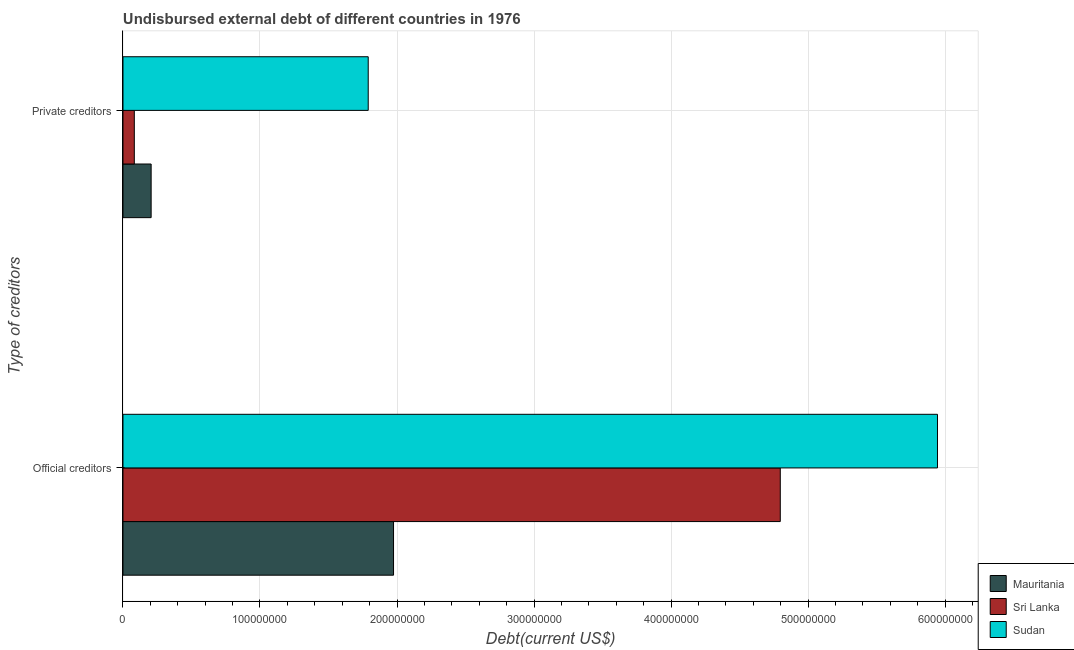Are the number of bars per tick equal to the number of legend labels?
Your response must be concise. Yes. How many bars are there on the 1st tick from the bottom?
Provide a succinct answer. 3. What is the label of the 2nd group of bars from the top?
Provide a short and direct response. Official creditors. What is the undisbursed external debt of private creditors in Sudan?
Provide a short and direct response. 1.79e+08. Across all countries, what is the maximum undisbursed external debt of official creditors?
Offer a very short reply. 5.94e+08. Across all countries, what is the minimum undisbursed external debt of official creditors?
Your answer should be very brief. 1.97e+08. In which country was the undisbursed external debt of private creditors maximum?
Offer a very short reply. Sudan. In which country was the undisbursed external debt of official creditors minimum?
Your response must be concise. Mauritania. What is the total undisbursed external debt of official creditors in the graph?
Provide a succinct answer. 1.27e+09. What is the difference between the undisbursed external debt of official creditors in Sudan and that in Mauritania?
Provide a succinct answer. 3.97e+08. What is the difference between the undisbursed external debt of private creditors in Mauritania and the undisbursed external debt of official creditors in Sri Lanka?
Provide a short and direct response. -4.59e+08. What is the average undisbursed external debt of private creditors per country?
Offer a very short reply. 6.93e+07. What is the difference between the undisbursed external debt of official creditors and undisbursed external debt of private creditors in Sri Lanka?
Your answer should be very brief. 4.71e+08. In how many countries, is the undisbursed external debt of official creditors greater than 340000000 US$?
Your answer should be very brief. 2. What is the ratio of the undisbursed external debt of official creditors in Sri Lanka to that in Sudan?
Your answer should be compact. 0.81. In how many countries, is the undisbursed external debt of private creditors greater than the average undisbursed external debt of private creditors taken over all countries?
Your response must be concise. 1. What does the 1st bar from the top in Private creditors represents?
Provide a short and direct response. Sudan. What does the 3rd bar from the bottom in Official creditors represents?
Offer a very short reply. Sudan. How many countries are there in the graph?
Give a very brief answer. 3. What is the difference between two consecutive major ticks on the X-axis?
Keep it short and to the point. 1.00e+08. Are the values on the major ticks of X-axis written in scientific E-notation?
Provide a short and direct response. No. Does the graph contain grids?
Give a very brief answer. Yes. How many legend labels are there?
Provide a short and direct response. 3. What is the title of the graph?
Make the answer very short. Undisbursed external debt of different countries in 1976. What is the label or title of the X-axis?
Provide a succinct answer. Debt(current US$). What is the label or title of the Y-axis?
Offer a terse response. Type of creditors. What is the Debt(current US$) in Mauritania in Official creditors?
Your response must be concise. 1.97e+08. What is the Debt(current US$) of Sri Lanka in Official creditors?
Provide a short and direct response. 4.80e+08. What is the Debt(current US$) of Sudan in Official creditors?
Your response must be concise. 5.94e+08. What is the Debt(current US$) in Mauritania in Private creditors?
Keep it short and to the point. 2.05e+07. What is the Debt(current US$) in Sri Lanka in Private creditors?
Keep it short and to the point. 8.28e+06. What is the Debt(current US$) in Sudan in Private creditors?
Give a very brief answer. 1.79e+08. Across all Type of creditors, what is the maximum Debt(current US$) of Mauritania?
Your answer should be compact. 1.97e+08. Across all Type of creditors, what is the maximum Debt(current US$) in Sri Lanka?
Keep it short and to the point. 4.80e+08. Across all Type of creditors, what is the maximum Debt(current US$) of Sudan?
Offer a very short reply. 5.94e+08. Across all Type of creditors, what is the minimum Debt(current US$) of Mauritania?
Your response must be concise. 2.05e+07. Across all Type of creditors, what is the minimum Debt(current US$) in Sri Lanka?
Offer a very short reply. 8.28e+06. Across all Type of creditors, what is the minimum Debt(current US$) of Sudan?
Provide a short and direct response. 1.79e+08. What is the total Debt(current US$) in Mauritania in the graph?
Provide a succinct answer. 2.18e+08. What is the total Debt(current US$) in Sri Lanka in the graph?
Provide a short and direct response. 4.88e+08. What is the total Debt(current US$) in Sudan in the graph?
Give a very brief answer. 7.73e+08. What is the difference between the Debt(current US$) of Mauritania in Official creditors and that in Private creditors?
Provide a succinct answer. 1.77e+08. What is the difference between the Debt(current US$) of Sri Lanka in Official creditors and that in Private creditors?
Your answer should be very brief. 4.71e+08. What is the difference between the Debt(current US$) in Sudan in Official creditors and that in Private creditors?
Offer a very short reply. 4.16e+08. What is the difference between the Debt(current US$) in Mauritania in Official creditors and the Debt(current US$) in Sri Lanka in Private creditors?
Offer a terse response. 1.89e+08. What is the difference between the Debt(current US$) in Mauritania in Official creditors and the Debt(current US$) in Sudan in Private creditors?
Ensure brevity in your answer.  1.85e+07. What is the difference between the Debt(current US$) in Sri Lanka in Official creditors and the Debt(current US$) in Sudan in Private creditors?
Provide a short and direct response. 3.01e+08. What is the average Debt(current US$) in Mauritania per Type of creditors?
Offer a very short reply. 1.09e+08. What is the average Debt(current US$) of Sri Lanka per Type of creditors?
Make the answer very short. 2.44e+08. What is the average Debt(current US$) in Sudan per Type of creditors?
Your answer should be compact. 3.87e+08. What is the difference between the Debt(current US$) of Mauritania and Debt(current US$) of Sri Lanka in Official creditors?
Your answer should be compact. -2.82e+08. What is the difference between the Debt(current US$) in Mauritania and Debt(current US$) in Sudan in Official creditors?
Your response must be concise. -3.97e+08. What is the difference between the Debt(current US$) in Sri Lanka and Debt(current US$) in Sudan in Official creditors?
Provide a short and direct response. -1.15e+08. What is the difference between the Debt(current US$) in Mauritania and Debt(current US$) in Sri Lanka in Private creditors?
Give a very brief answer. 1.23e+07. What is the difference between the Debt(current US$) in Mauritania and Debt(current US$) in Sudan in Private creditors?
Your answer should be compact. -1.58e+08. What is the difference between the Debt(current US$) of Sri Lanka and Debt(current US$) of Sudan in Private creditors?
Give a very brief answer. -1.71e+08. What is the ratio of the Debt(current US$) of Mauritania in Official creditors to that in Private creditors?
Offer a very short reply. 9.61. What is the ratio of the Debt(current US$) of Sri Lanka in Official creditors to that in Private creditors?
Give a very brief answer. 57.97. What is the ratio of the Debt(current US$) of Sudan in Official creditors to that in Private creditors?
Provide a succinct answer. 3.32. What is the difference between the highest and the second highest Debt(current US$) in Mauritania?
Keep it short and to the point. 1.77e+08. What is the difference between the highest and the second highest Debt(current US$) in Sri Lanka?
Your answer should be very brief. 4.71e+08. What is the difference between the highest and the second highest Debt(current US$) of Sudan?
Offer a very short reply. 4.16e+08. What is the difference between the highest and the lowest Debt(current US$) of Mauritania?
Your answer should be very brief. 1.77e+08. What is the difference between the highest and the lowest Debt(current US$) in Sri Lanka?
Make the answer very short. 4.71e+08. What is the difference between the highest and the lowest Debt(current US$) in Sudan?
Your answer should be very brief. 4.16e+08. 